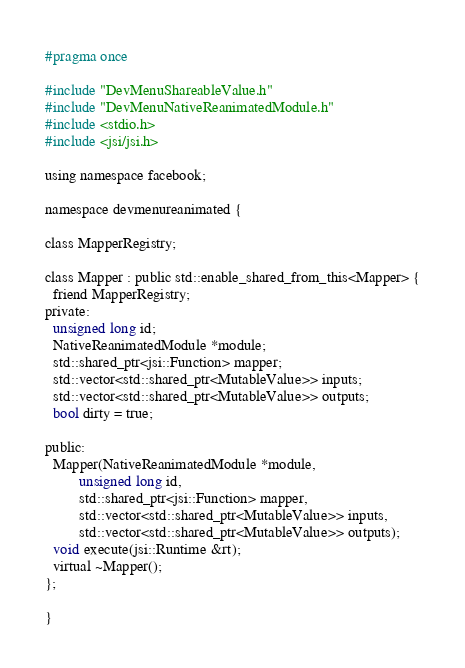<code> <loc_0><loc_0><loc_500><loc_500><_C_>#pragma once

#include "DevMenuShareableValue.h"
#include "DevMenuNativeReanimatedModule.h"
#include <stdio.h>
#include <jsi/jsi.h>

using namespace facebook;

namespace devmenureanimated {

class MapperRegistry;

class Mapper : public std::enable_shared_from_this<Mapper> {
  friend MapperRegistry;
private:
  unsigned long id;
  NativeReanimatedModule *module;
  std::shared_ptr<jsi::Function> mapper;
  std::vector<std::shared_ptr<MutableValue>> inputs;
  std::vector<std::shared_ptr<MutableValue>> outputs;
  bool dirty = true;

public:
  Mapper(NativeReanimatedModule *module,
         unsigned long id,
         std::shared_ptr<jsi::Function> mapper,
         std::vector<std::shared_ptr<MutableValue>> inputs,
         std::vector<std::shared_ptr<MutableValue>> outputs);
  void execute(jsi::Runtime &rt);
  virtual ~Mapper();
};

}
</code> 